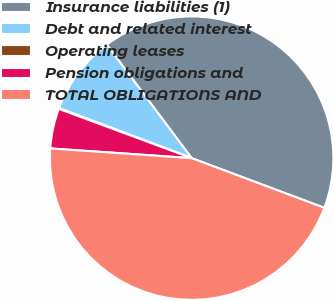Convert chart to OTSL. <chart><loc_0><loc_0><loc_500><loc_500><pie_chart><fcel>Insurance liabilities (1)<fcel>Debt and related interest<fcel>Operating leases<fcel>Pension obligations and<fcel>TOTAL OBLIGATIONS AND<nl><fcel>40.92%<fcel>9.04%<fcel>0.09%<fcel>4.56%<fcel>45.39%<nl></chart> 